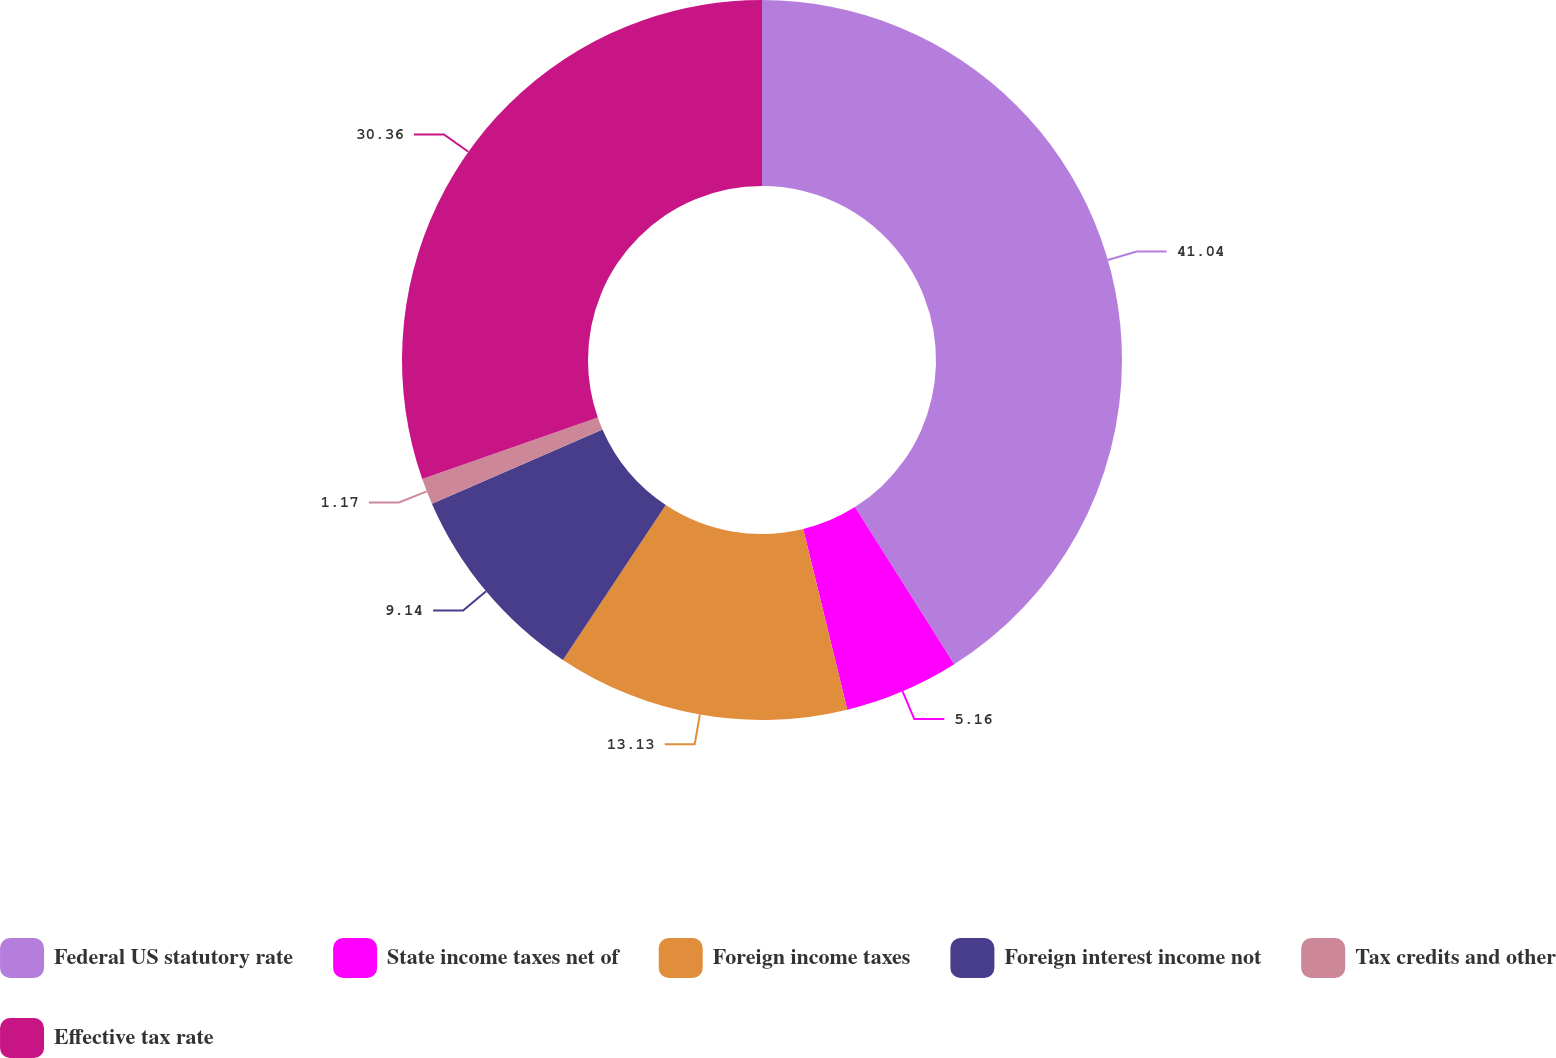<chart> <loc_0><loc_0><loc_500><loc_500><pie_chart><fcel>Federal US statutory rate<fcel>State income taxes net of<fcel>Foreign income taxes<fcel>Foreign interest income not<fcel>Tax credits and other<fcel>Effective tax rate<nl><fcel>41.03%<fcel>5.16%<fcel>13.13%<fcel>9.14%<fcel>1.17%<fcel>30.36%<nl></chart> 